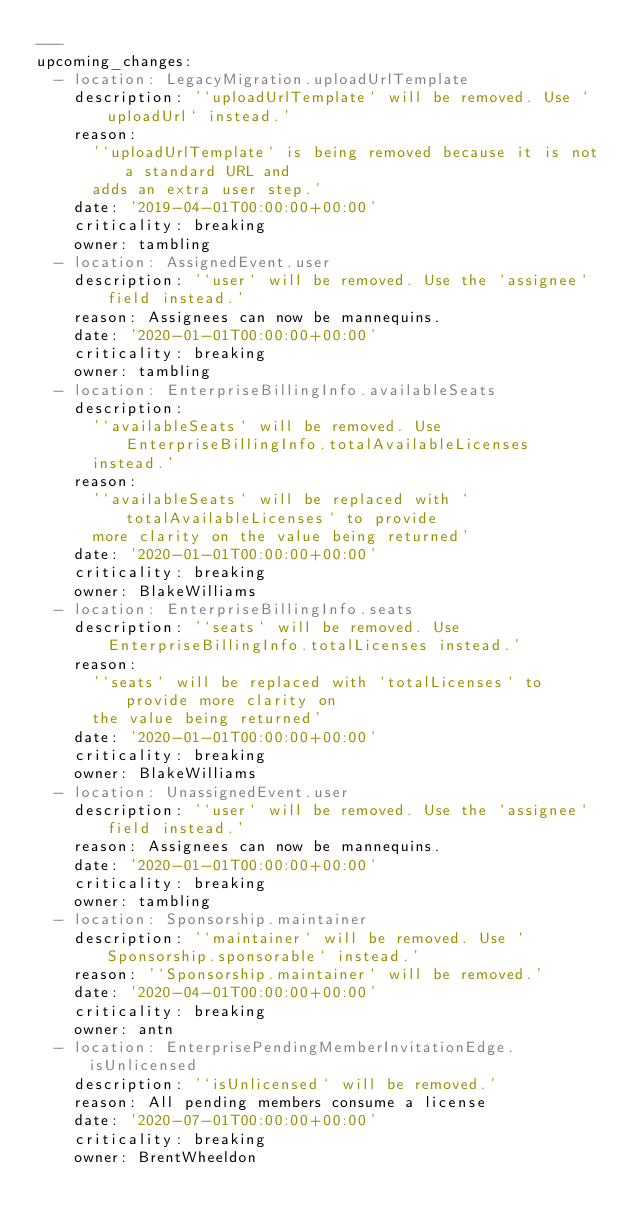Convert code to text. <code><loc_0><loc_0><loc_500><loc_500><_YAML_>---
upcoming_changes:
  - location: LegacyMigration.uploadUrlTemplate
    description: '`uploadUrlTemplate` will be removed. Use `uploadUrl` instead.'
    reason:
      '`uploadUrlTemplate` is being removed because it is not a standard URL and
      adds an extra user step.'
    date: '2019-04-01T00:00:00+00:00'
    criticality: breaking
    owner: tambling
  - location: AssignedEvent.user
    description: '`user` will be removed. Use the `assignee` field instead.'
    reason: Assignees can now be mannequins.
    date: '2020-01-01T00:00:00+00:00'
    criticality: breaking
    owner: tambling
  - location: EnterpriseBillingInfo.availableSeats
    description:
      '`availableSeats` will be removed. Use EnterpriseBillingInfo.totalAvailableLicenses
      instead.'
    reason:
      '`availableSeats` will be replaced with `totalAvailableLicenses` to provide
      more clarity on the value being returned'
    date: '2020-01-01T00:00:00+00:00'
    criticality: breaking
    owner: BlakeWilliams
  - location: EnterpriseBillingInfo.seats
    description: '`seats` will be removed. Use EnterpriseBillingInfo.totalLicenses instead.'
    reason:
      '`seats` will be replaced with `totalLicenses` to provide more clarity on
      the value being returned'
    date: '2020-01-01T00:00:00+00:00'
    criticality: breaking
    owner: BlakeWilliams
  - location: UnassignedEvent.user
    description: '`user` will be removed. Use the `assignee` field instead.'
    reason: Assignees can now be mannequins.
    date: '2020-01-01T00:00:00+00:00'
    criticality: breaking
    owner: tambling
  - location: Sponsorship.maintainer
    description: '`maintainer` will be removed. Use `Sponsorship.sponsorable` instead.'
    reason: '`Sponsorship.maintainer` will be removed.'
    date: '2020-04-01T00:00:00+00:00'
    criticality: breaking
    owner: antn
  - location: EnterprisePendingMemberInvitationEdge.isUnlicensed
    description: '`isUnlicensed` will be removed.'
    reason: All pending members consume a license
    date: '2020-07-01T00:00:00+00:00'
    criticality: breaking
    owner: BrentWheeldon</code> 